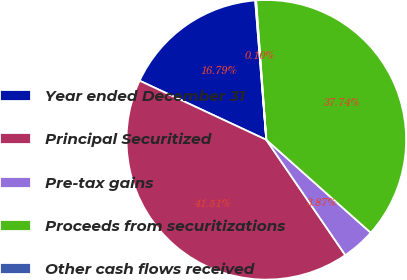Convert chart. <chart><loc_0><loc_0><loc_500><loc_500><pie_chart><fcel>Year ended December 31<fcel>Principal Securitized<fcel>Pre-tax gains<fcel>Proceeds from securitizations<fcel>Other cash flows received<nl><fcel>16.79%<fcel>41.51%<fcel>3.87%<fcel>37.74%<fcel>0.1%<nl></chart> 